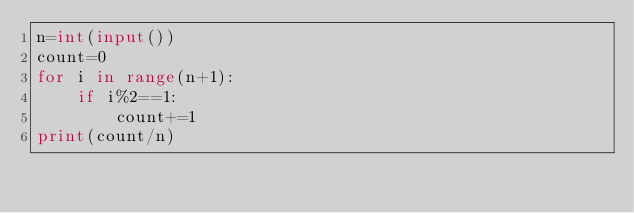Convert code to text. <code><loc_0><loc_0><loc_500><loc_500><_Python_>n=int(input())
count=0
for i in range(n+1):
    if i%2==1:
        count+=1
print(count/n)</code> 